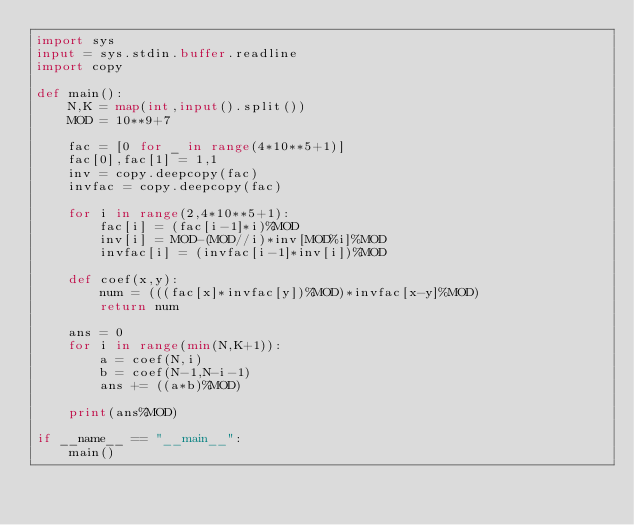Convert code to text. <code><loc_0><loc_0><loc_500><loc_500><_Python_>import sys
input = sys.stdin.buffer.readline
import copy

def main():
    N,K = map(int,input().split())
    MOD = 10**9+7

    fac = [0 for _ in range(4*10**5+1)]
    fac[0],fac[1] = 1,1
    inv = copy.deepcopy(fac)
    invfac = copy.deepcopy(fac)
    
    for i in range(2,4*10**5+1):
        fac[i] = (fac[i-1]*i)%MOD
        inv[i] = MOD-(MOD//i)*inv[MOD%i]%MOD
        invfac[i] = (invfac[i-1]*inv[i])%MOD

    def coef(x,y):
        num = (((fac[x]*invfac[y])%MOD)*invfac[x-y]%MOD)
        return num
    
    ans = 0
    for i in range(min(N,K+1)):
        a = coef(N,i)
        b = coef(N-1,N-i-1)
        ans += ((a*b)%MOD)
        
    print(ans%MOD)
    
if __name__ == "__main__":
    main()</code> 